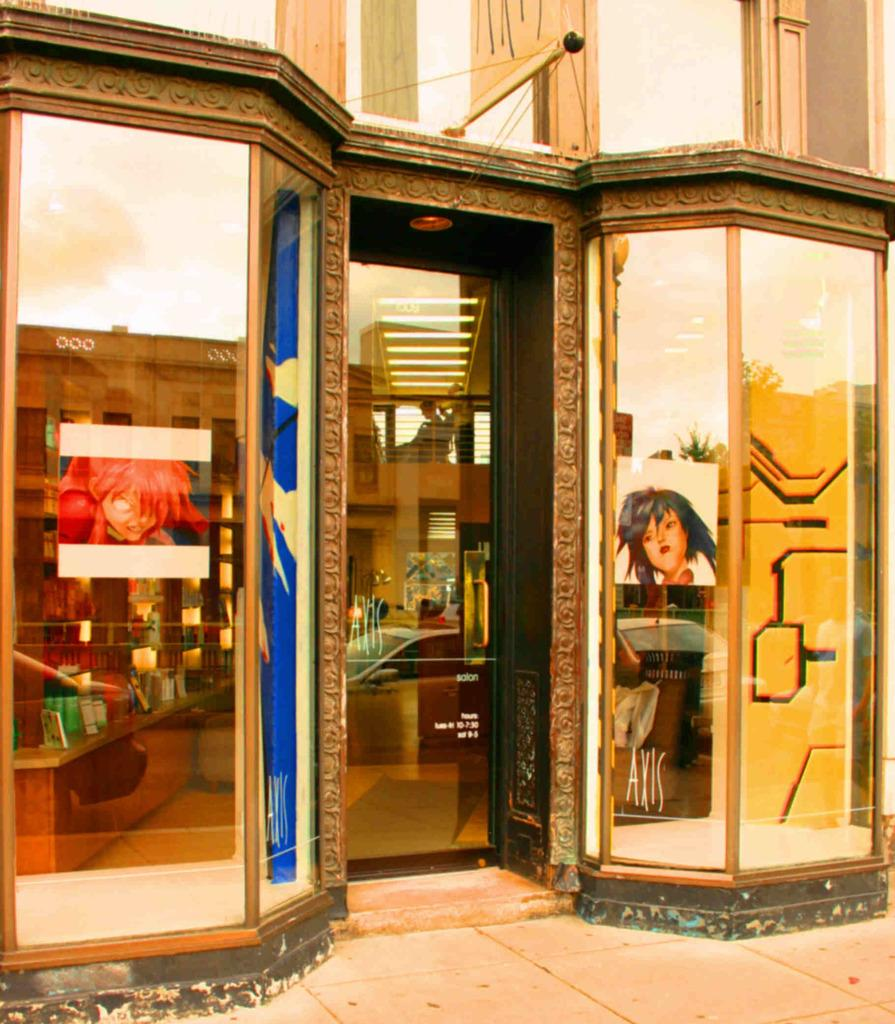What type of structure is visible in the image? There is a building in the image. What piece of furniture can be seen in the image? There is a table in the image. What architectural element is present in the image? There is a wall in the image. What type of decorations are present in the image? There are posters in the image. What type of items are on the left side of the image? There are cosmetic items on the left side of the image. How many sisters are visible in the image? There are no sisters present in the image. What type of heat source is used to warm the cosmetic items in the image? There is no heat source mentioned or visible in the image; it only shows cosmetic items on the left side. 